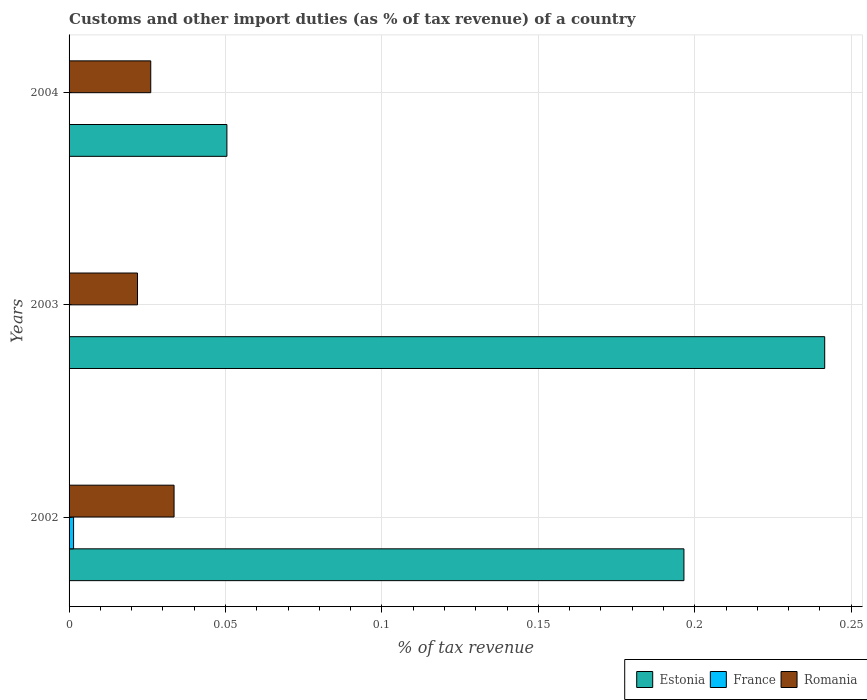How many different coloured bars are there?
Make the answer very short. 3. Are the number of bars per tick equal to the number of legend labels?
Your answer should be very brief. No. Are the number of bars on each tick of the Y-axis equal?
Make the answer very short. No. How many bars are there on the 2nd tick from the top?
Your answer should be compact. 2. How many bars are there on the 2nd tick from the bottom?
Your response must be concise. 2. What is the percentage of tax revenue from customs in France in 2002?
Offer a very short reply. 0. Across all years, what is the maximum percentage of tax revenue from customs in France?
Ensure brevity in your answer.  0. Across all years, what is the minimum percentage of tax revenue from customs in Estonia?
Your answer should be compact. 0.05. In which year was the percentage of tax revenue from customs in Romania maximum?
Provide a succinct answer. 2002. What is the total percentage of tax revenue from customs in Romania in the graph?
Your answer should be very brief. 0.08. What is the difference between the percentage of tax revenue from customs in Romania in 2002 and that in 2004?
Your answer should be very brief. 0.01. What is the difference between the percentage of tax revenue from customs in Romania in 2004 and the percentage of tax revenue from customs in Estonia in 2003?
Offer a terse response. -0.22. What is the average percentage of tax revenue from customs in Estonia per year?
Offer a very short reply. 0.16. In the year 2003, what is the difference between the percentage of tax revenue from customs in Estonia and percentage of tax revenue from customs in Romania?
Provide a succinct answer. 0.22. What is the ratio of the percentage of tax revenue from customs in Romania in 2003 to that in 2004?
Give a very brief answer. 0.84. Is the difference between the percentage of tax revenue from customs in Estonia in 2002 and 2004 greater than the difference between the percentage of tax revenue from customs in Romania in 2002 and 2004?
Ensure brevity in your answer.  Yes. What is the difference between the highest and the second highest percentage of tax revenue from customs in Romania?
Keep it short and to the point. 0.01. What is the difference between the highest and the lowest percentage of tax revenue from customs in France?
Offer a very short reply. 0. In how many years, is the percentage of tax revenue from customs in France greater than the average percentage of tax revenue from customs in France taken over all years?
Provide a succinct answer. 1. How many bars are there?
Your response must be concise. 7. Are the values on the major ticks of X-axis written in scientific E-notation?
Your answer should be very brief. No. Does the graph contain any zero values?
Offer a very short reply. Yes. Does the graph contain grids?
Ensure brevity in your answer.  Yes. How many legend labels are there?
Offer a terse response. 3. How are the legend labels stacked?
Offer a terse response. Horizontal. What is the title of the graph?
Offer a terse response. Customs and other import duties (as % of tax revenue) of a country. Does "Latvia" appear as one of the legend labels in the graph?
Ensure brevity in your answer.  No. What is the label or title of the X-axis?
Offer a very short reply. % of tax revenue. What is the % of tax revenue in Estonia in 2002?
Your answer should be compact. 0.2. What is the % of tax revenue of France in 2002?
Provide a succinct answer. 0. What is the % of tax revenue in Romania in 2002?
Provide a short and direct response. 0.03. What is the % of tax revenue in Estonia in 2003?
Provide a short and direct response. 0.24. What is the % of tax revenue in Romania in 2003?
Ensure brevity in your answer.  0.02. What is the % of tax revenue of Estonia in 2004?
Offer a very short reply. 0.05. What is the % of tax revenue of France in 2004?
Ensure brevity in your answer.  0. What is the % of tax revenue of Romania in 2004?
Offer a terse response. 0.03. Across all years, what is the maximum % of tax revenue of Estonia?
Your answer should be compact. 0.24. Across all years, what is the maximum % of tax revenue in France?
Your answer should be compact. 0. Across all years, what is the maximum % of tax revenue in Romania?
Offer a terse response. 0.03. Across all years, what is the minimum % of tax revenue of Estonia?
Provide a short and direct response. 0.05. Across all years, what is the minimum % of tax revenue in France?
Your answer should be very brief. 0. Across all years, what is the minimum % of tax revenue of Romania?
Provide a short and direct response. 0.02. What is the total % of tax revenue in Estonia in the graph?
Offer a terse response. 0.49. What is the total % of tax revenue in France in the graph?
Give a very brief answer. 0. What is the total % of tax revenue of Romania in the graph?
Offer a terse response. 0.08. What is the difference between the % of tax revenue of Estonia in 2002 and that in 2003?
Ensure brevity in your answer.  -0.04. What is the difference between the % of tax revenue of Romania in 2002 and that in 2003?
Your response must be concise. 0.01. What is the difference between the % of tax revenue in Estonia in 2002 and that in 2004?
Provide a short and direct response. 0.15. What is the difference between the % of tax revenue in Romania in 2002 and that in 2004?
Your response must be concise. 0.01. What is the difference between the % of tax revenue of Estonia in 2003 and that in 2004?
Make the answer very short. 0.19. What is the difference between the % of tax revenue in Romania in 2003 and that in 2004?
Offer a terse response. -0. What is the difference between the % of tax revenue of Estonia in 2002 and the % of tax revenue of Romania in 2003?
Provide a succinct answer. 0.17. What is the difference between the % of tax revenue of France in 2002 and the % of tax revenue of Romania in 2003?
Your answer should be compact. -0.02. What is the difference between the % of tax revenue in Estonia in 2002 and the % of tax revenue in Romania in 2004?
Ensure brevity in your answer.  0.17. What is the difference between the % of tax revenue of France in 2002 and the % of tax revenue of Romania in 2004?
Offer a very short reply. -0.02. What is the difference between the % of tax revenue of Estonia in 2003 and the % of tax revenue of Romania in 2004?
Offer a very short reply. 0.22. What is the average % of tax revenue in Estonia per year?
Your answer should be compact. 0.16. What is the average % of tax revenue of Romania per year?
Make the answer very short. 0.03. In the year 2002, what is the difference between the % of tax revenue in Estonia and % of tax revenue in France?
Provide a succinct answer. 0.2. In the year 2002, what is the difference between the % of tax revenue in Estonia and % of tax revenue in Romania?
Give a very brief answer. 0.16. In the year 2002, what is the difference between the % of tax revenue in France and % of tax revenue in Romania?
Ensure brevity in your answer.  -0.03. In the year 2003, what is the difference between the % of tax revenue in Estonia and % of tax revenue in Romania?
Keep it short and to the point. 0.22. In the year 2004, what is the difference between the % of tax revenue in Estonia and % of tax revenue in Romania?
Make the answer very short. 0.02. What is the ratio of the % of tax revenue in Estonia in 2002 to that in 2003?
Offer a terse response. 0.81. What is the ratio of the % of tax revenue in Romania in 2002 to that in 2003?
Your response must be concise. 1.53. What is the ratio of the % of tax revenue of Estonia in 2002 to that in 2004?
Give a very brief answer. 3.9. What is the ratio of the % of tax revenue in Romania in 2002 to that in 2004?
Your answer should be very brief. 1.29. What is the ratio of the % of tax revenue of Estonia in 2003 to that in 2004?
Give a very brief answer. 4.79. What is the ratio of the % of tax revenue in Romania in 2003 to that in 2004?
Keep it short and to the point. 0.84. What is the difference between the highest and the second highest % of tax revenue in Estonia?
Ensure brevity in your answer.  0.04. What is the difference between the highest and the second highest % of tax revenue in Romania?
Make the answer very short. 0.01. What is the difference between the highest and the lowest % of tax revenue of Estonia?
Your answer should be very brief. 0.19. What is the difference between the highest and the lowest % of tax revenue of France?
Give a very brief answer. 0. What is the difference between the highest and the lowest % of tax revenue in Romania?
Provide a succinct answer. 0.01. 